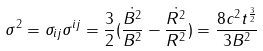Convert formula to latex. <formula><loc_0><loc_0><loc_500><loc_500>\sigma ^ { 2 } = \sigma _ { i j } \sigma ^ { i j } = \frac { 3 } { 2 } ( \frac { \dot { B ^ { 2 } } } { B ^ { 2 } } - \frac { \dot { R ^ { 2 } } } { R ^ { 2 } } ) = \frac { 8 c ^ { 2 } t ^ { \frac { 3 } { 2 } } } { 3 B ^ { 2 } }</formula> 